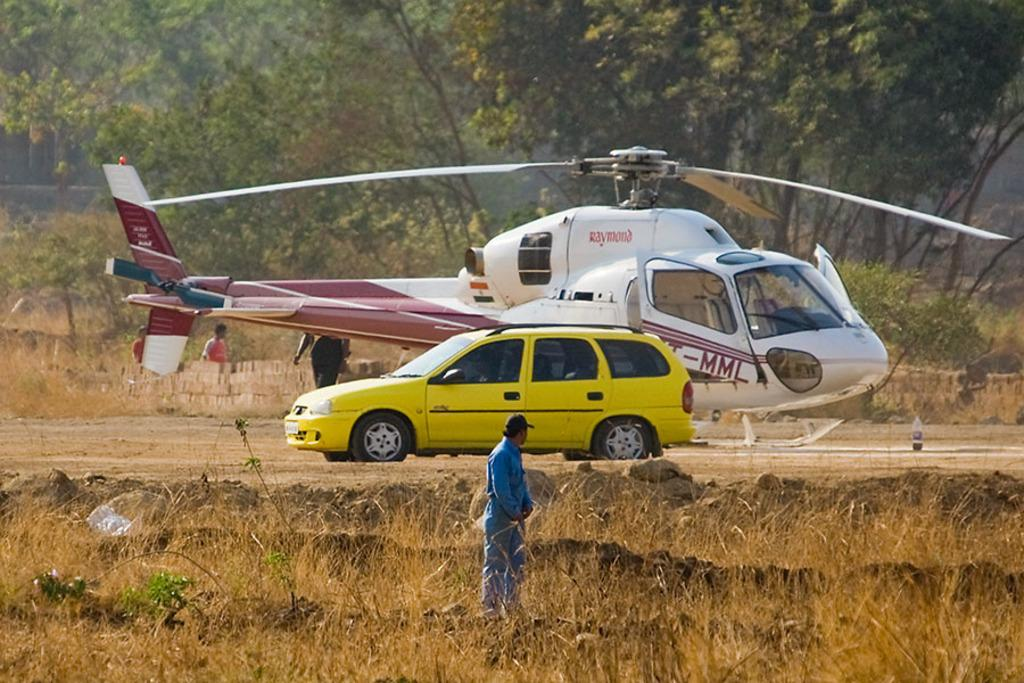What is the main subject of the image? The main subject of the image is a helicopter. What other objects can be seen on the ground in the image? There is a yellow car on the ground in the image. What type of natural environment is visible at the bottom of the image? There are plants and grass at the bottom of the image. Can you describe the people visible in the image? Yes, there are people visible in the image. What is the background of the image composed of? The background of the image includes many trees. How much payment is required to use the helicopter's stomach in the image? There is no mention of a helicopter's stomach in the image, and payment is not relevant to the image's content. 